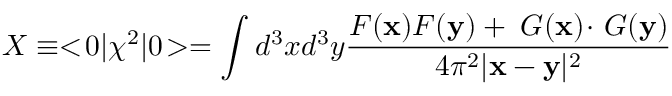<formula> <loc_0><loc_0><loc_500><loc_500>X \equiv < \, 0 | \chi ^ { 2 } | 0 \, > = \int d ^ { 3 } x d ^ { 3 } y { \frac { F ( x ) F ( y ) + \nabla G ( x ) \, \cdot \, \nabla G ( y ) } { 4 \pi ^ { 2 } | x - y | ^ { 2 } } }</formula> 